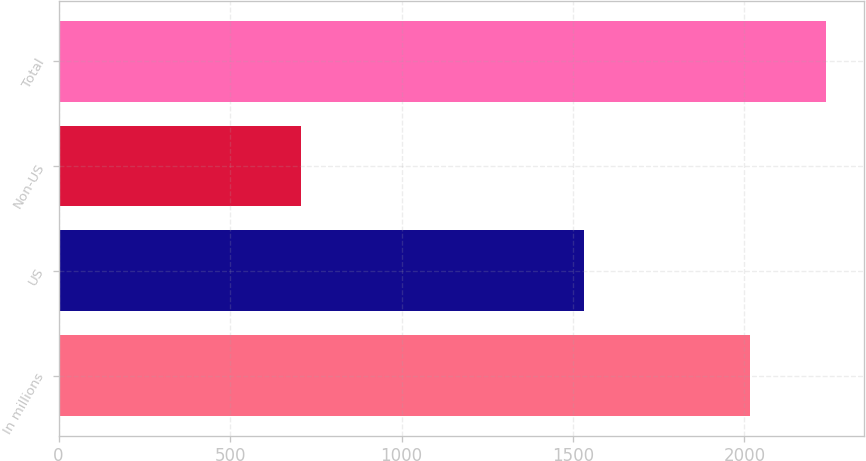<chart> <loc_0><loc_0><loc_500><loc_500><bar_chart><fcel>In millions<fcel>US<fcel>Non-US<fcel>Total<nl><fcel>2016<fcel>1531.2<fcel>706.8<fcel>2238<nl></chart> 